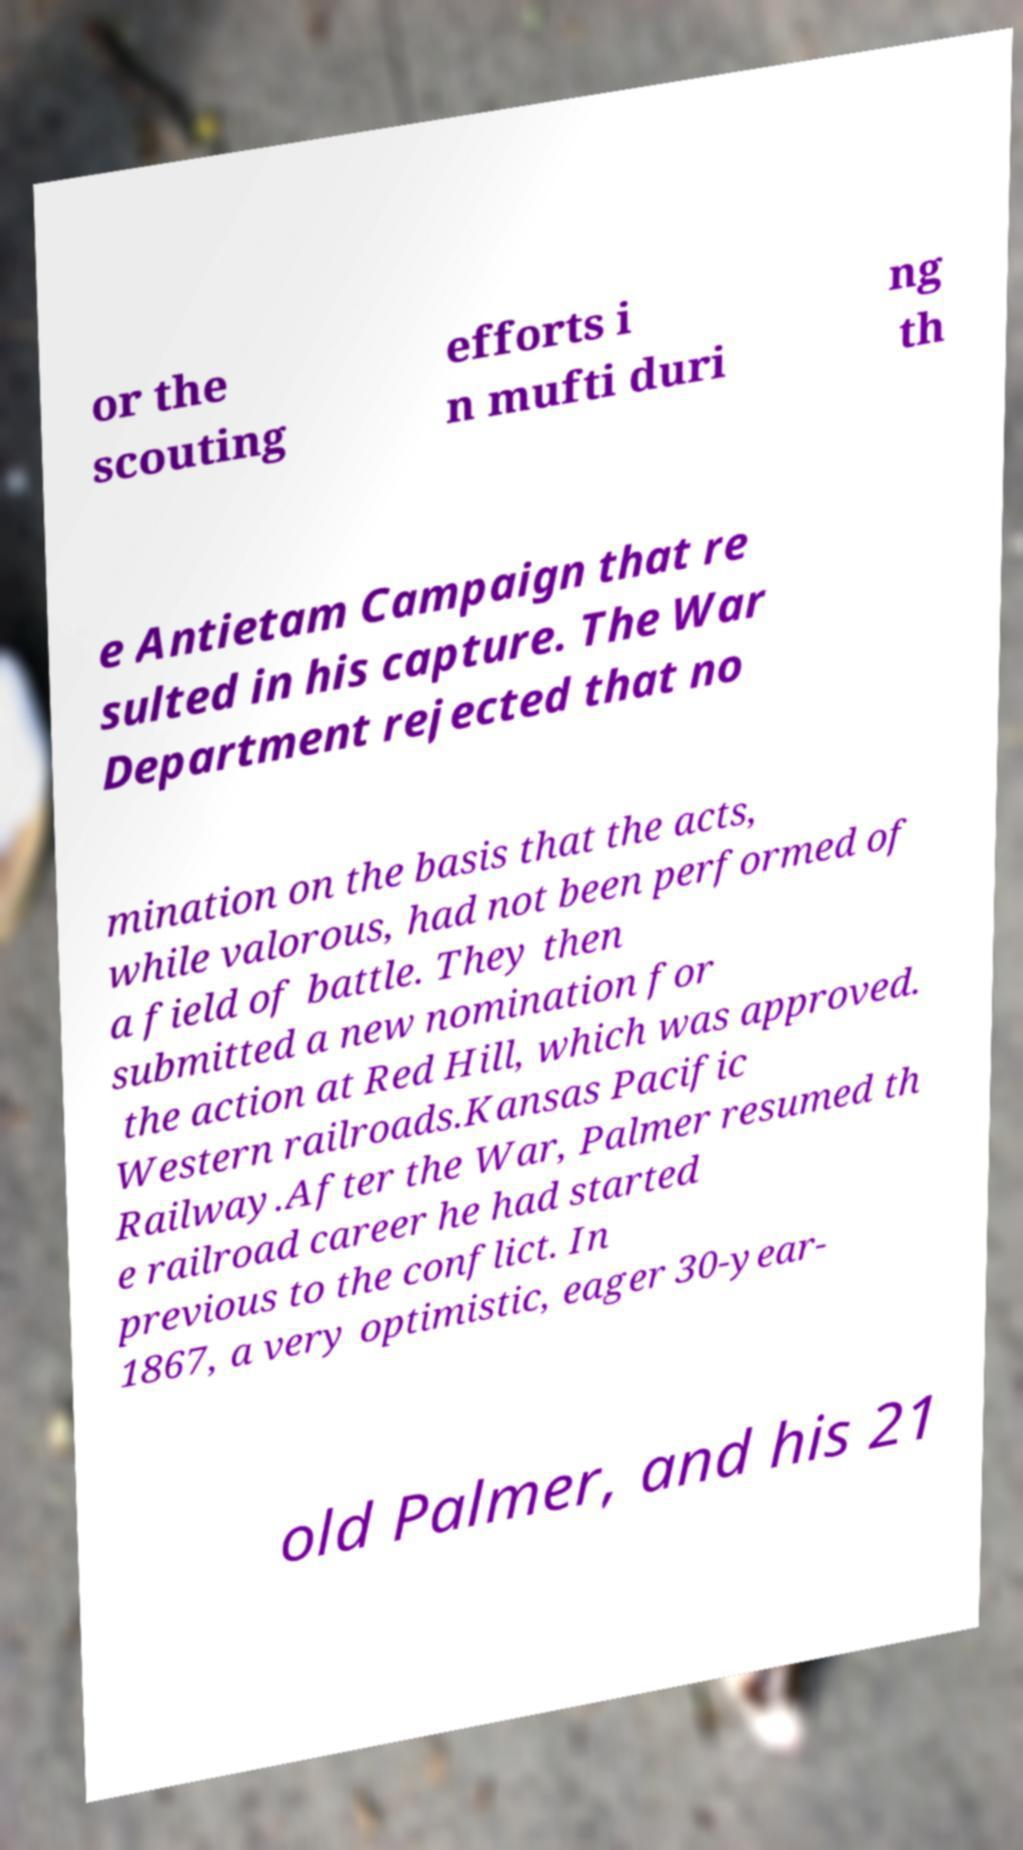For documentation purposes, I need the text within this image transcribed. Could you provide that? or the scouting efforts i n mufti duri ng th e Antietam Campaign that re sulted in his capture. The War Department rejected that no mination on the basis that the acts, while valorous, had not been performed of a field of battle. They then submitted a new nomination for the action at Red Hill, which was approved. Western railroads.Kansas Pacific Railway.After the War, Palmer resumed th e railroad career he had started previous to the conflict. In 1867, a very optimistic, eager 30-year- old Palmer, and his 21 